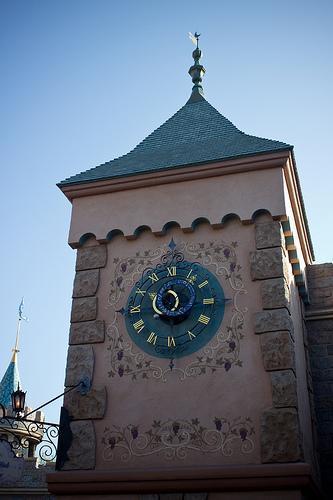How many clocks?
Give a very brief answer. 1. 